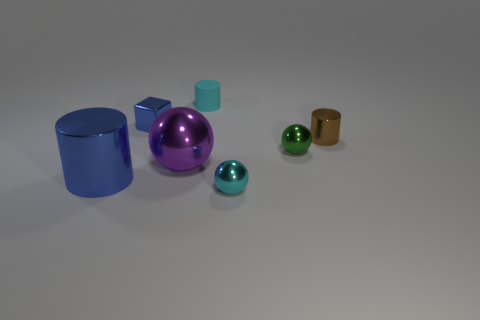Does the cyan thing to the right of the cyan cylinder have the same size as the purple ball?
Your answer should be very brief. No. The metal object that is the same color as the large metal cylinder is what size?
Keep it short and to the point. Small. Are there more large cylinders in front of the big purple metallic thing than large green metal cylinders?
Offer a very short reply. Yes. Does the green object have the same material as the tiny cyan ball?
Offer a terse response. Yes. How many other things are the same shape as the brown metal thing?
Your answer should be compact. 2. Are there any other things that have the same material as the small cyan cylinder?
Your answer should be very brief. No. There is a tiny cylinder that is to the right of the shiny sphere on the right side of the small ball that is left of the green ball; what is its color?
Your answer should be very brief. Brown. Does the small shiny thing in front of the small green shiny sphere have the same shape as the green object?
Your answer should be compact. Yes. What number of big rubber cubes are there?
Your answer should be very brief. 0. What number of green metal objects have the same size as the blue metallic cylinder?
Provide a succinct answer. 0. 